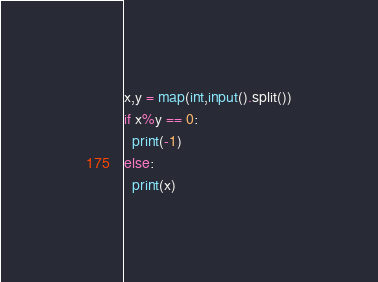<code> <loc_0><loc_0><loc_500><loc_500><_Python_>x,y = map(int,input().split())
if x%y == 0:
  print(-1)
else:
  print(x)
</code> 